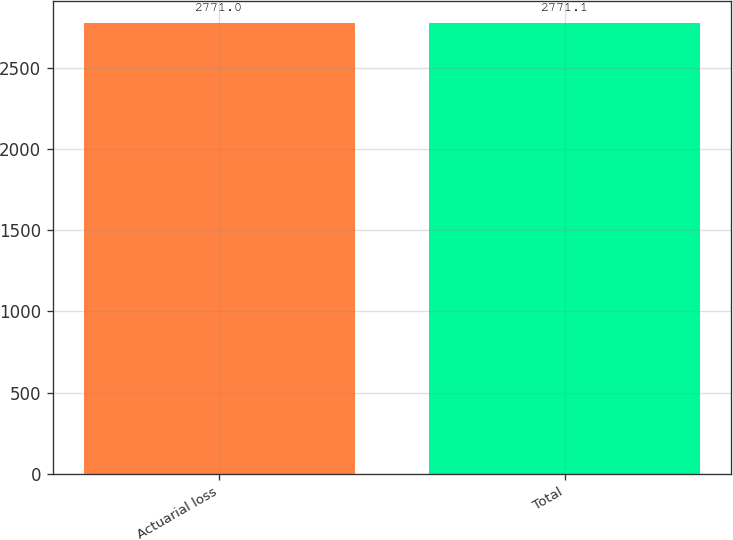Convert chart to OTSL. <chart><loc_0><loc_0><loc_500><loc_500><bar_chart><fcel>Actuarial loss<fcel>Total<nl><fcel>2771<fcel>2771.1<nl></chart> 